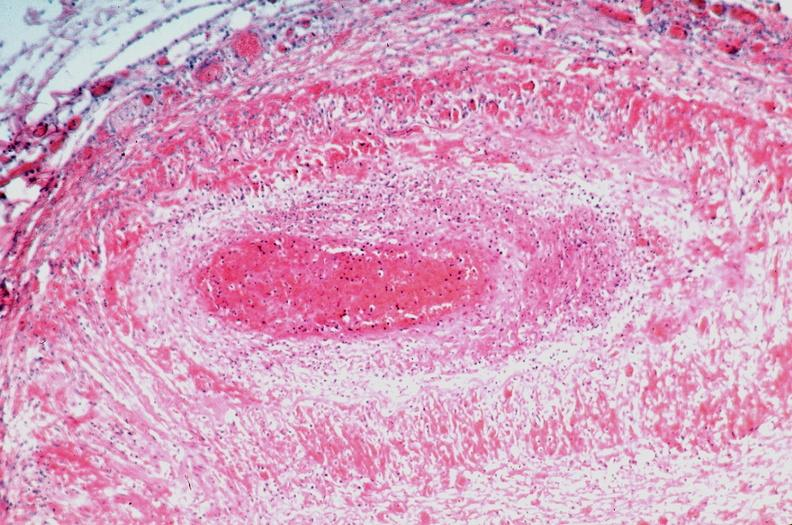does this image show vasculitis, polyarteritis nodosa?
Answer the question using a single word or phrase. Yes 